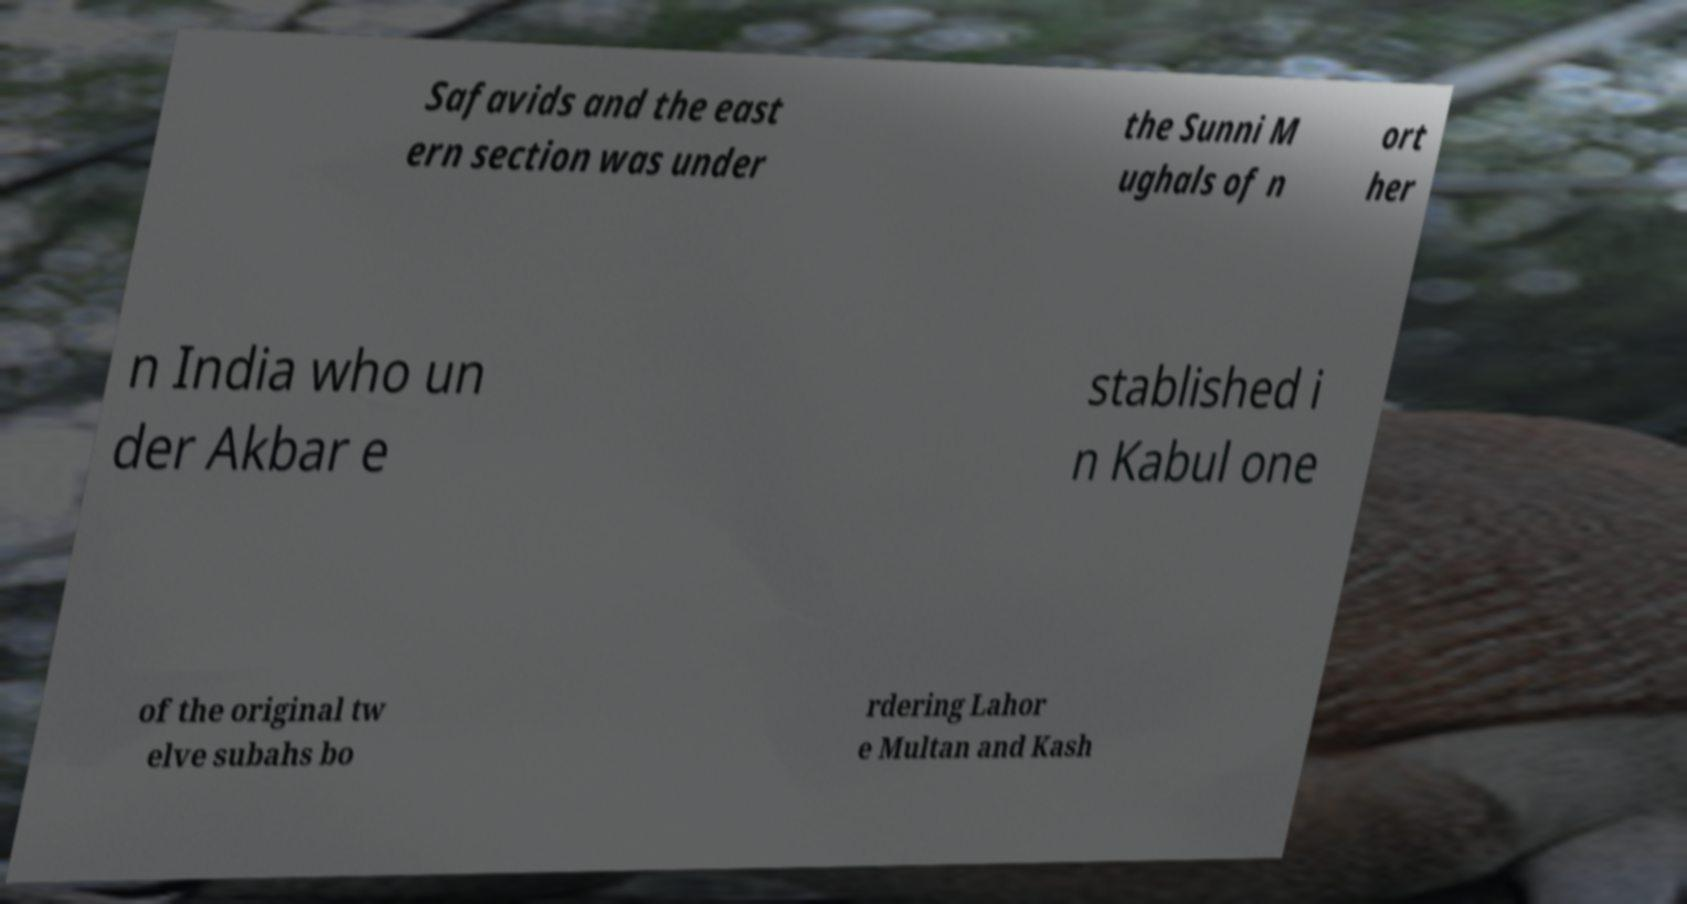Please read and relay the text visible in this image. What does it say? Safavids and the east ern section was under the Sunni M ughals of n ort her n India who un der Akbar e stablished i n Kabul one of the original tw elve subahs bo rdering Lahor e Multan and Kash 